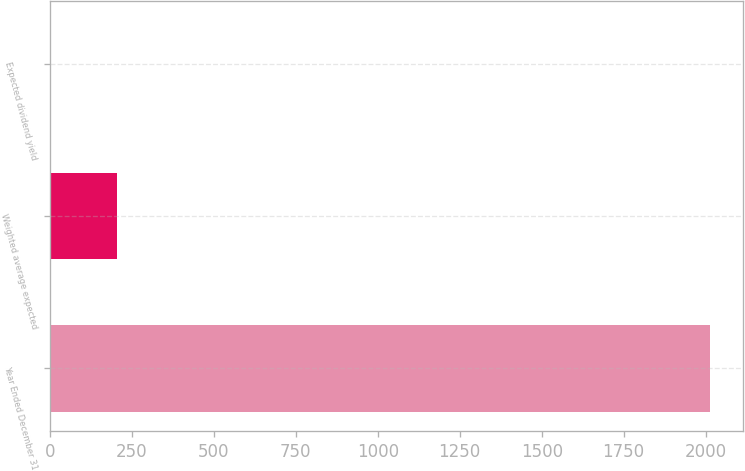<chart> <loc_0><loc_0><loc_500><loc_500><bar_chart><fcel>Year Ended December 31<fcel>Weighted average expected<fcel>Expected dividend yield<nl><fcel>2014<fcel>203.65<fcel>2.5<nl></chart> 